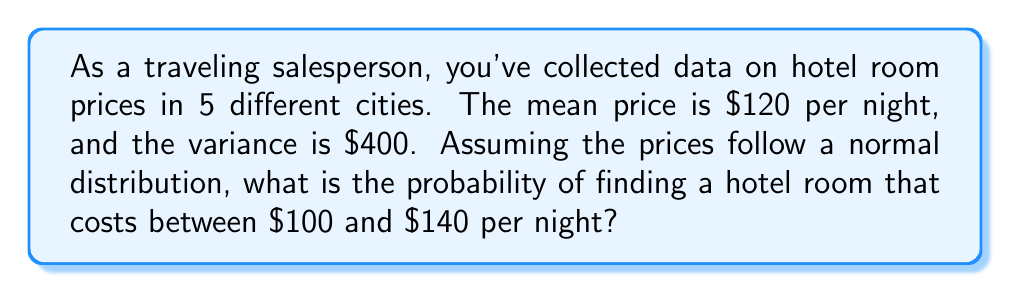Show me your answer to this math problem. Let's approach this step-by-step:

1) We're given that the hotel room prices follow a normal distribution with:
   Mean (μ) = $120
   Variance (σ²) = $400

2) To find the standard deviation (σ), we take the square root of the variance:
   σ = √$400 = $20

3) We want to find the probability of a room costing between $100 and $140.
   We need to standardize these values using the z-score formula:
   z = (x - μ) / σ

4) For $100: z₁ = ($100 - $120) / $20 = -1
   For $140: z₂ = ($140 - $120) / $20 = 1

5) We're looking for P($100 < X < $140), which is equivalent to P(-1 < Z < 1)

6) Using the standard normal distribution table or a calculator:
   P(-1 < Z < 1) = P(Z < 1) - P(Z < -1)
                 = 0.8413 - 0.1587
                 = 0.6826

7) Convert to percentage: 0.6826 * 100 = 68.26%

Therefore, the probability of finding a hotel room that costs between $100 and $140 per night is approximately 68.26%.
Answer: 68.26% 